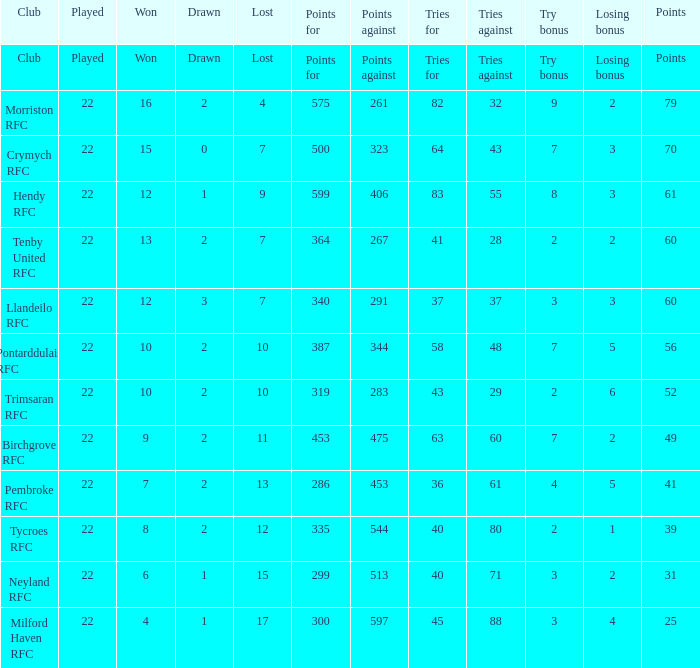What is the won when the points against are 597? 4.0. 